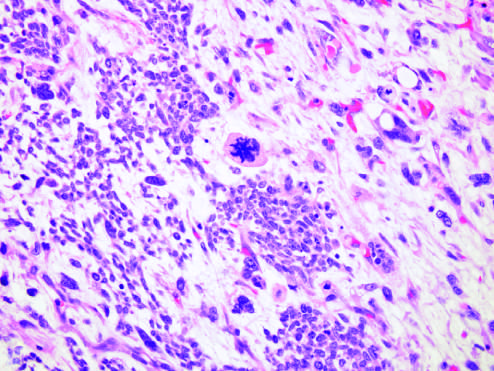what was present within this wilms tumor, characterized by cells with hyperchromatic, pleomorphic nuclei, and an abnormal mitosis center of field?
Answer the question using a single word or phrase. Focal anaplasia 